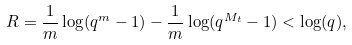Convert formula to latex. <formula><loc_0><loc_0><loc_500><loc_500>R = \frac { 1 } { m } \log ( q ^ { m } - 1 ) - \frac { 1 } { m } \log ( q ^ { M _ { t } } - 1 ) < \log ( q ) ,</formula> 